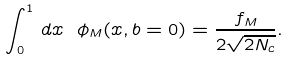<formula> <loc_0><loc_0><loc_500><loc_500>\int _ { 0 } ^ { 1 } \, d x \ \phi _ { M } ( x , b = 0 ) = \frac { f _ { M } } { 2 \sqrt { 2 N _ { c } } } .</formula> 